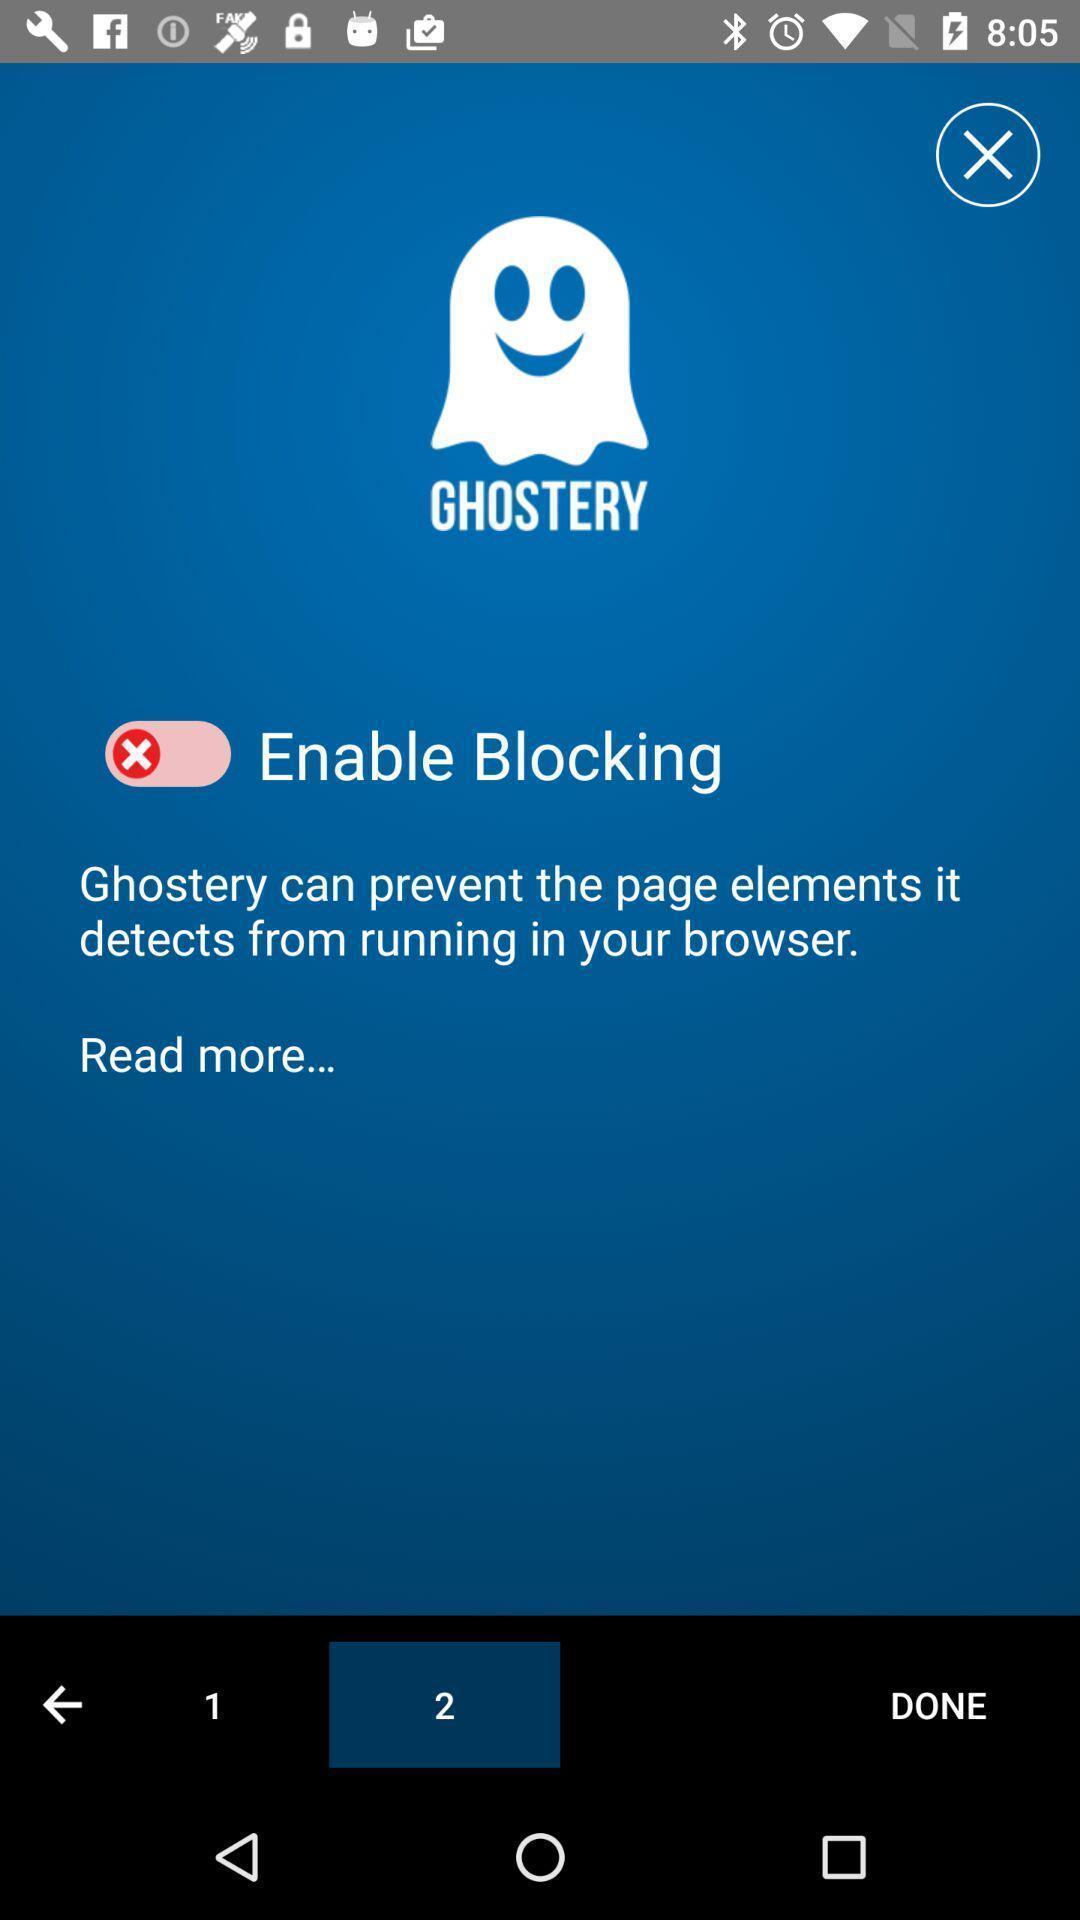Provide a detailed account of this screenshot. Starting page. 